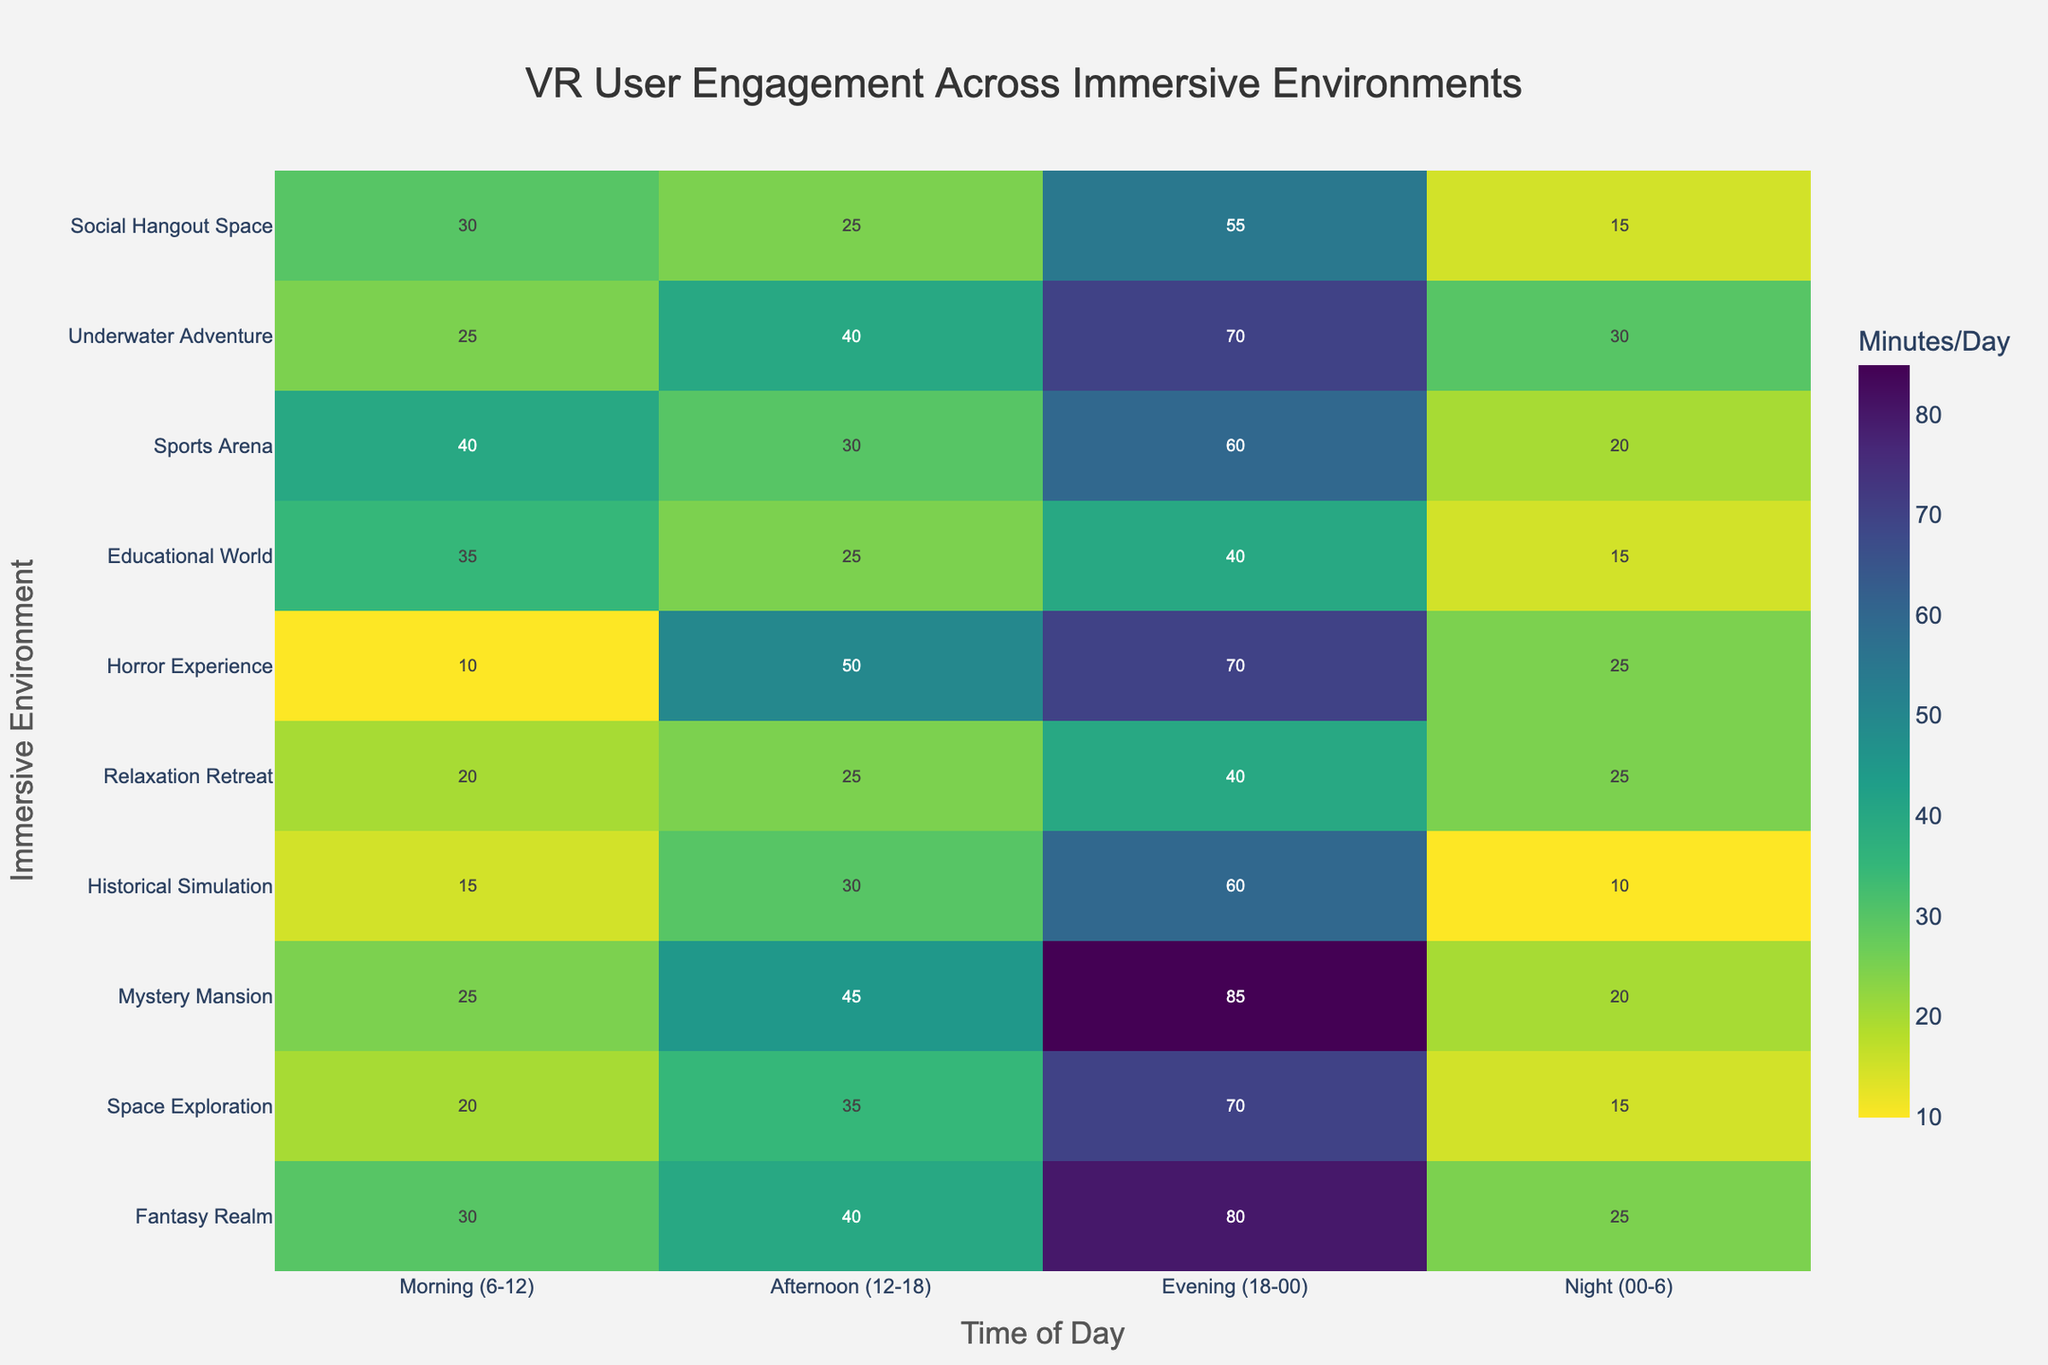What is the title of the heatmap? The title of the heatmap is located at the top center of the figure. It summarizes what the heatmap is about.
Answer: VR User Engagement Across Immersive Environments Which immersive environment shows the highest user engagement in the evening time period? To find the highest user engagement for the evening (18-00), locate the column labeled "Evening (18-00)" and identify the cell with the highest value.
Answer: Mystery Mansion What time period generally has the lowest user engagement across most environments? Observe each column and compare the combined intensity of colors. The time period with less bright colors across multiple rows indicates the lowest engagement.
Answer: Night (00-6) Which environment has the maximum overall user engagement across all time periods? Sum the engagement values for each environment and compare to find the environment with the highest total sum. Adding the total for each row: Fantasy Realm (175), Space Exploration (140), Mystery Mansion (175), Historical Simulation (115), Relaxation Retreat (110), Horror Experience (155), Educational World (115), Sports Arena (150), Underwater Adventure (165), Social Hangout Space (125).
Answer: Fantasy Realm and Mystery Mansion What's the average user engagement for "Social Hangout Space" across all time periods? Sum the values of "Social Hangout Space" across all time periods and divide by the number of periods: (30 + 25 + 55 + 15) / 4.
Answer: 31.25 How does user engagement in "Sports Arena" during the afternoon compare to the same period for "Historical Simulation"? Locate the values for "Sports Arena" and "Historical Simulation" during the "Afternoon (12-18)" and compare them.
Answer: 40 vs 30 Which time period shows the most diverse user engagement patterns across different environments? Look for the column with the greatest variety in color intensities, indicating high variability.
Answer: Afternoon (12-18) What is the combined user engagement for "Horror Experience" during the morning and evening? Sum the values for morning (6-12) and evening (18-00) in "Horror Experience": 10 (Morning) + 70 (Evening).
Answer: 80 Is the user engagement in "Educational World" higher in the morning or afternoon? Compare the engagement values of "Educational World" for 'Morning (6-12)' and 'Afternoon (12-18)'.
Answer: Morning (35) vs Afternoon (25) What time period shows the peak engagement for "Fantasy Realm"? Locate the row for "Fantasy Realm" and identify the maximum value among the different time periods.
Answer: Evening (80) 